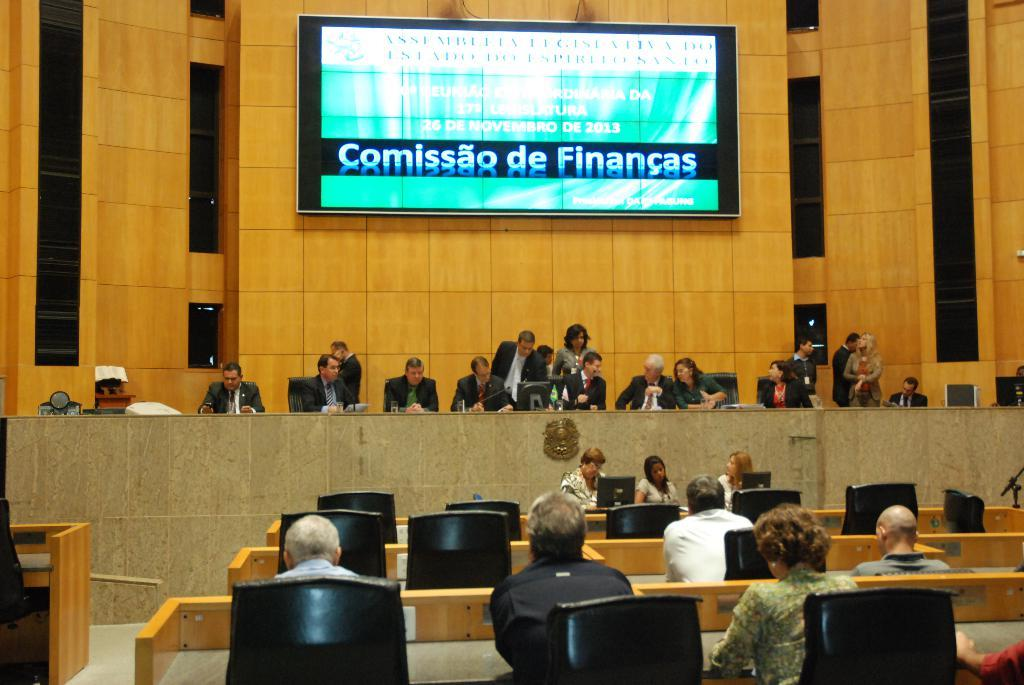What are the people in the image doing? There are people sitting on chairs and standing in the image. What can be seen in the background of the image? There is a wall and a huge screen in the background of the image. How many toes does the sister have in the image? There is no sister present in the image, so it is not possible to determine the number of toes she might have. 